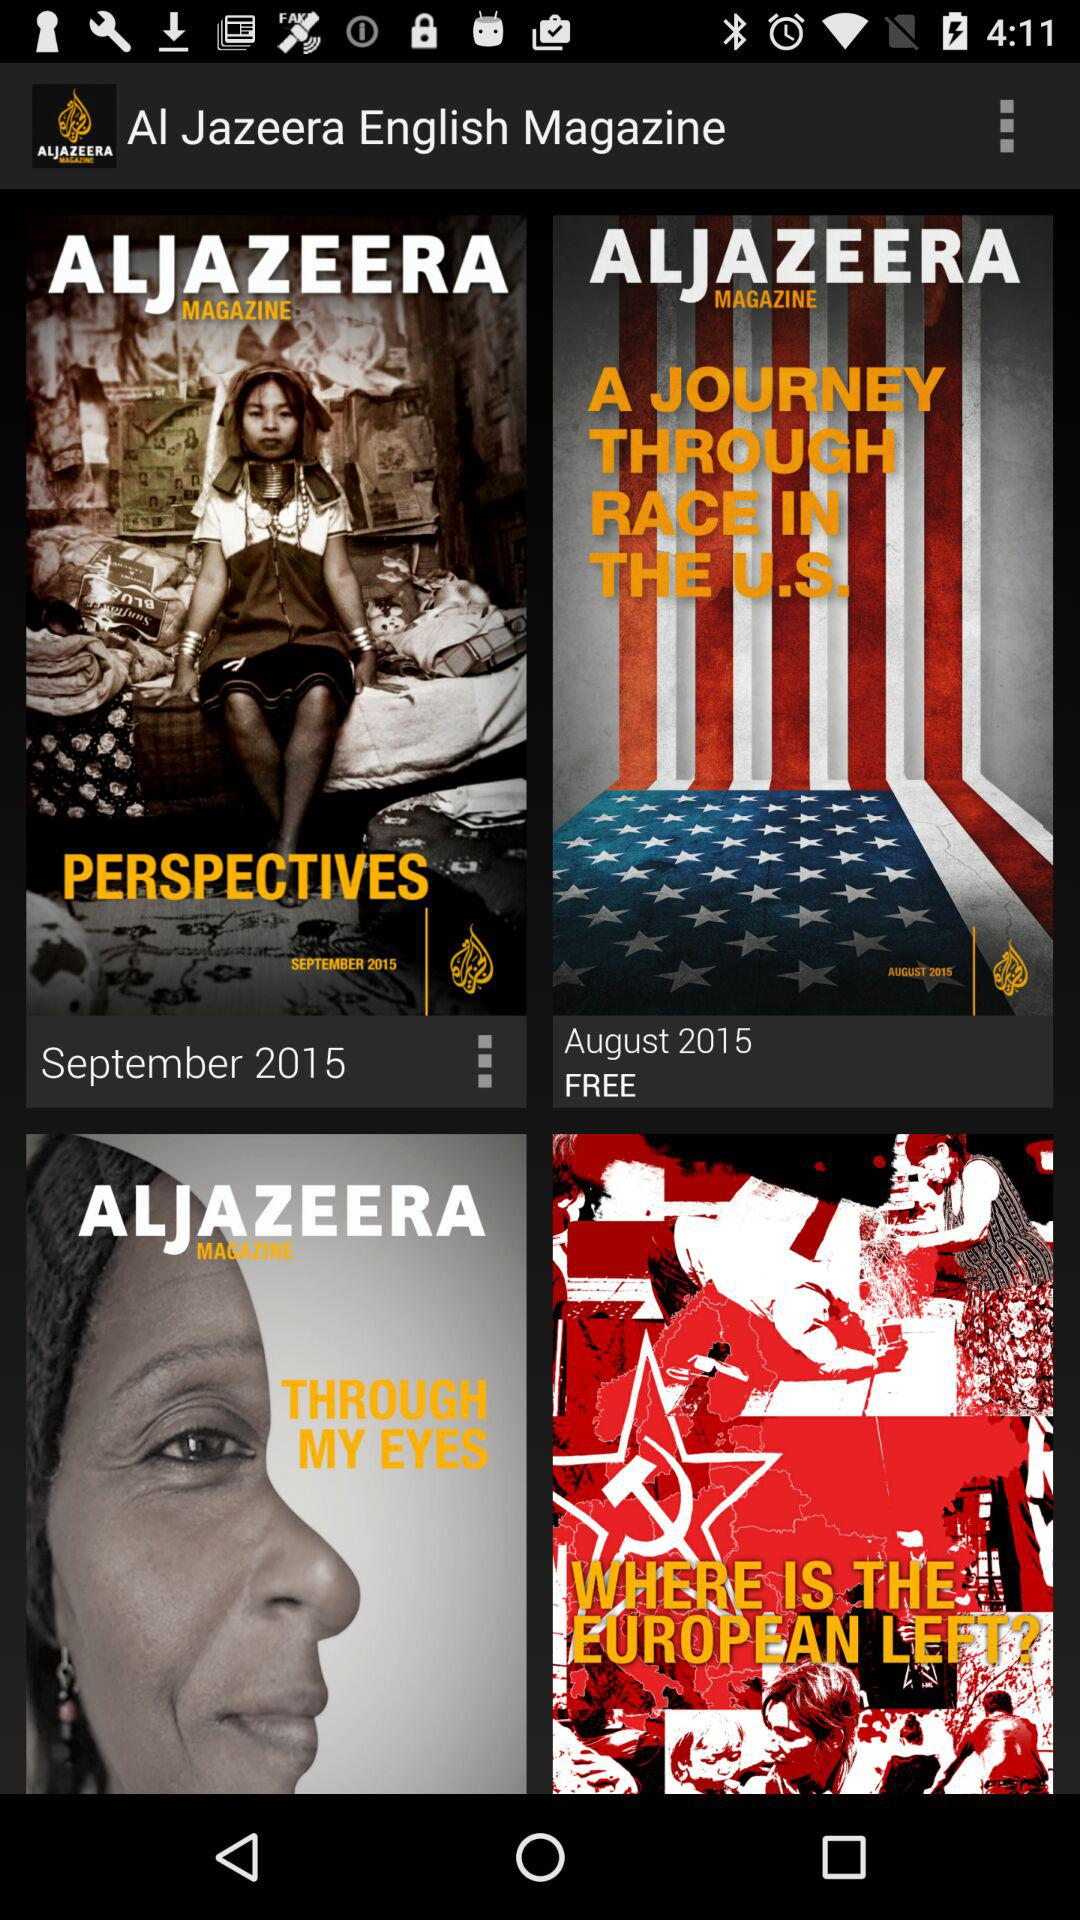What magazine has a September date? The magazine, which has a September date, is Al Jazeera. 